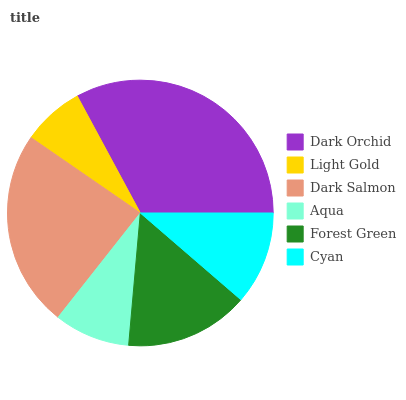Is Light Gold the minimum?
Answer yes or no. Yes. Is Dark Orchid the maximum?
Answer yes or no. Yes. Is Dark Salmon the minimum?
Answer yes or no. No. Is Dark Salmon the maximum?
Answer yes or no. No. Is Dark Salmon greater than Light Gold?
Answer yes or no. Yes. Is Light Gold less than Dark Salmon?
Answer yes or no. Yes. Is Light Gold greater than Dark Salmon?
Answer yes or no. No. Is Dark Salmon less than Light Gold?
Answer yes or no. No. Is Forest Green the high median?
Answer yes or no. Yes. Is Cyan the low median?
Answer yes or no. Yes. Is Cyan the high median?
Answer yes or no. No. Is Dark Orchid the low median?
Answer yes or no. No. 